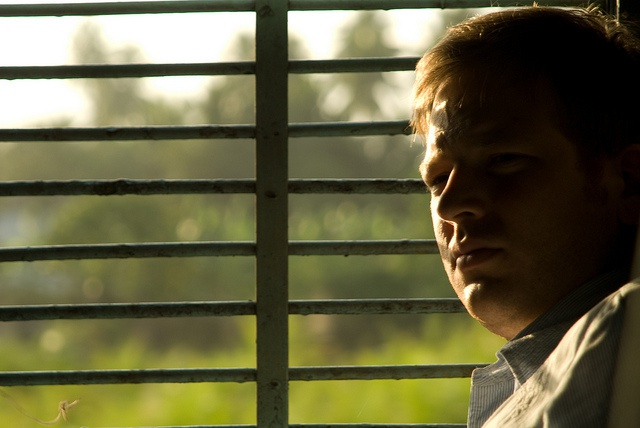Describe the objects in this image and their specific colors. I can see people in white, black, tan, maroon, and olive tones in this image. 